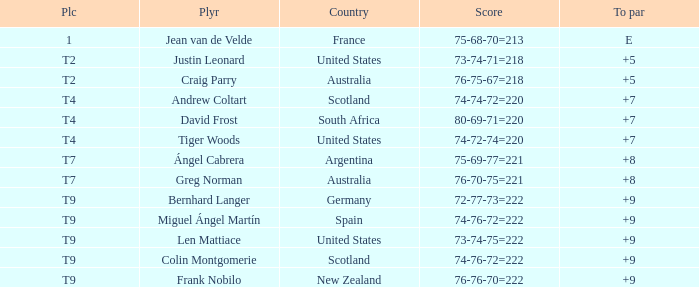For the match in which player David Frost scored a To Par of +7, what was the final score? 80-69-71=220. 